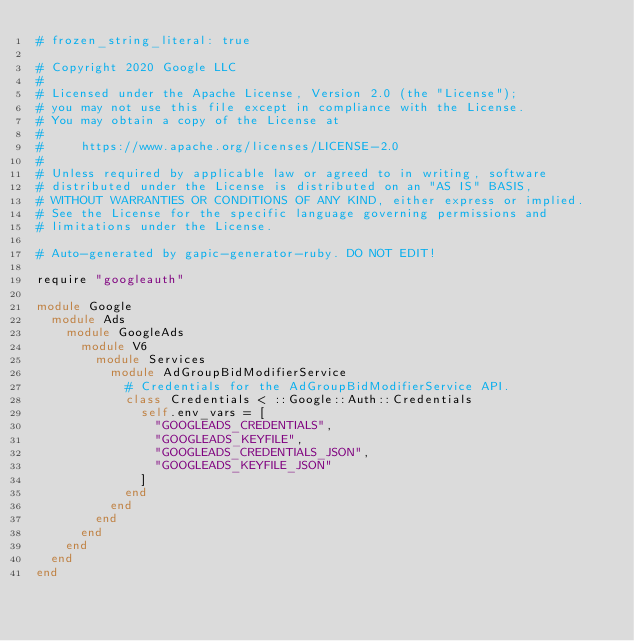<code> <loc_0><loc_0><loc_500><loc_500><_Ruby_># frozen_string_literal: true

# Copyright 2020 Google LLC
#
# Licensed under the Apache License, Version 2.0 (the "License");
# you may not use this file except in compliance with the License.
# You may obtain a copy of the License at
#
#     https://www.apache.org/licenses/LICENSE-2.0
#
# Unless required by applicable law or agreed to in writing, software
# distributed under the License is distributed on an "AS IS" BASIS,
# WITHOUT WARRANTIES OR CONDITIONS OF ANY KIND, either express or implied.
# See the License for the specific language governing permissions and
# limitations under the License.

# Auto-generated by gapic-generator-ruby. DO NOT EDIT!

require "googleauth"

module Google
  module Ads
    module GoogleAds
      module V6
        module Services
          module AdGroupBidModifierService
            # Credentials for the AdGroupBidModifierService API.
            class Credentials < ::Google::Auth::Credentials
              self.env_vars = [
                "GOOGLEADS_CREDENTIALS",
                "GOOGLEADS_KEYFILE",
                "GOOGLEADS_CREDENTIALS_JSON",
                "GOOGLEADS_KEYFILE_JSON"
              ]
            end
          end
        end
      end
    end
  end
end
</code> 